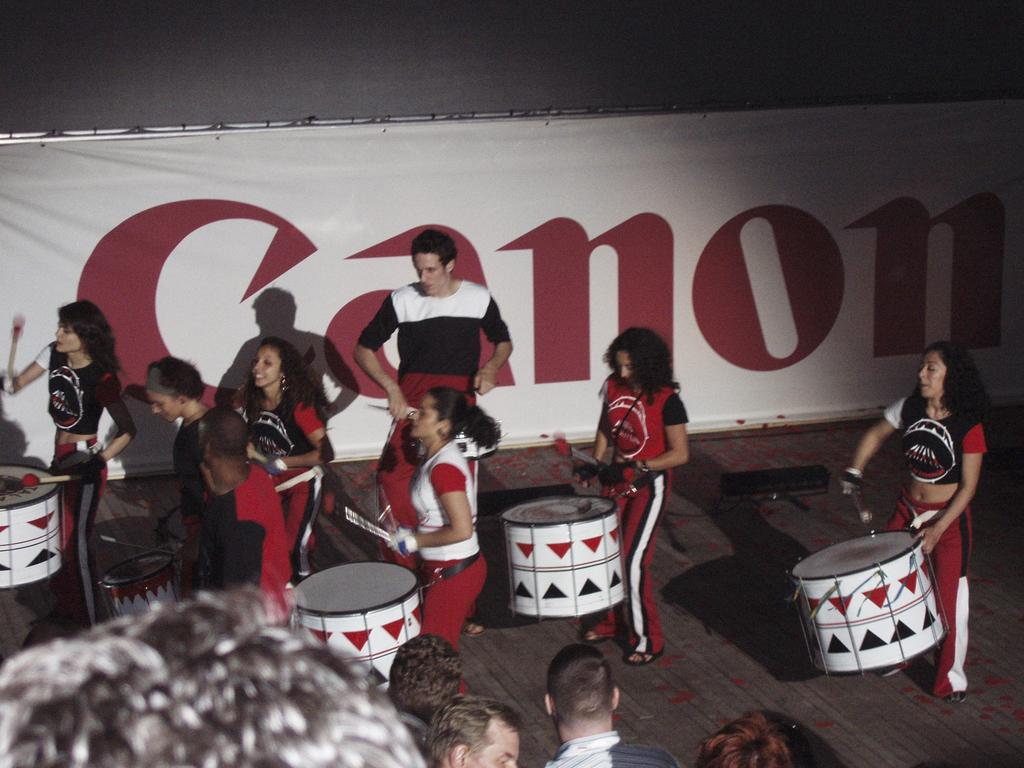What are the girls doing in the image? The girls are playing a drum in the image. What are the girls using to play the drum? The girls are using drumsticks to play the drum. What is the man in the image doing? The man is staring at the girls in the image. What can be seen in the background of the image? There is a banner in the background of the image. What type of paint is being used on the art displayed on the window in the image? There is no art displayed on a window in the image; the only objects mentioned are the girls playing a drum, drumsticks, a man staring, and a banner in the background. 